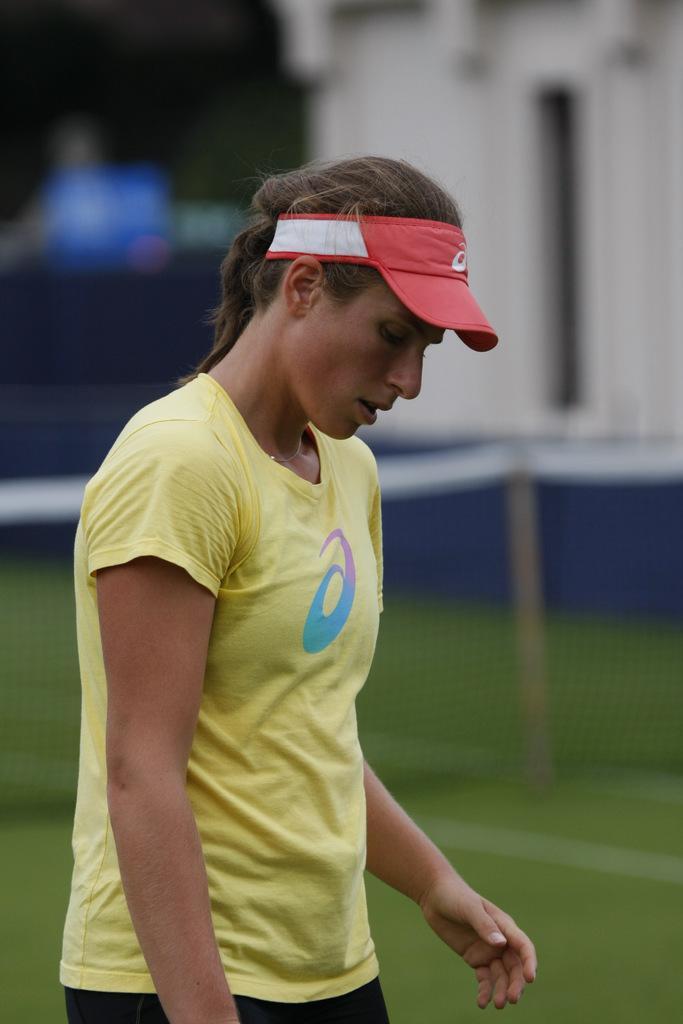Please provide a concise description of this image. In this image I can see the person and the person is wearing yellow color t-shirt and I can see the net and I can see the blurred background. 